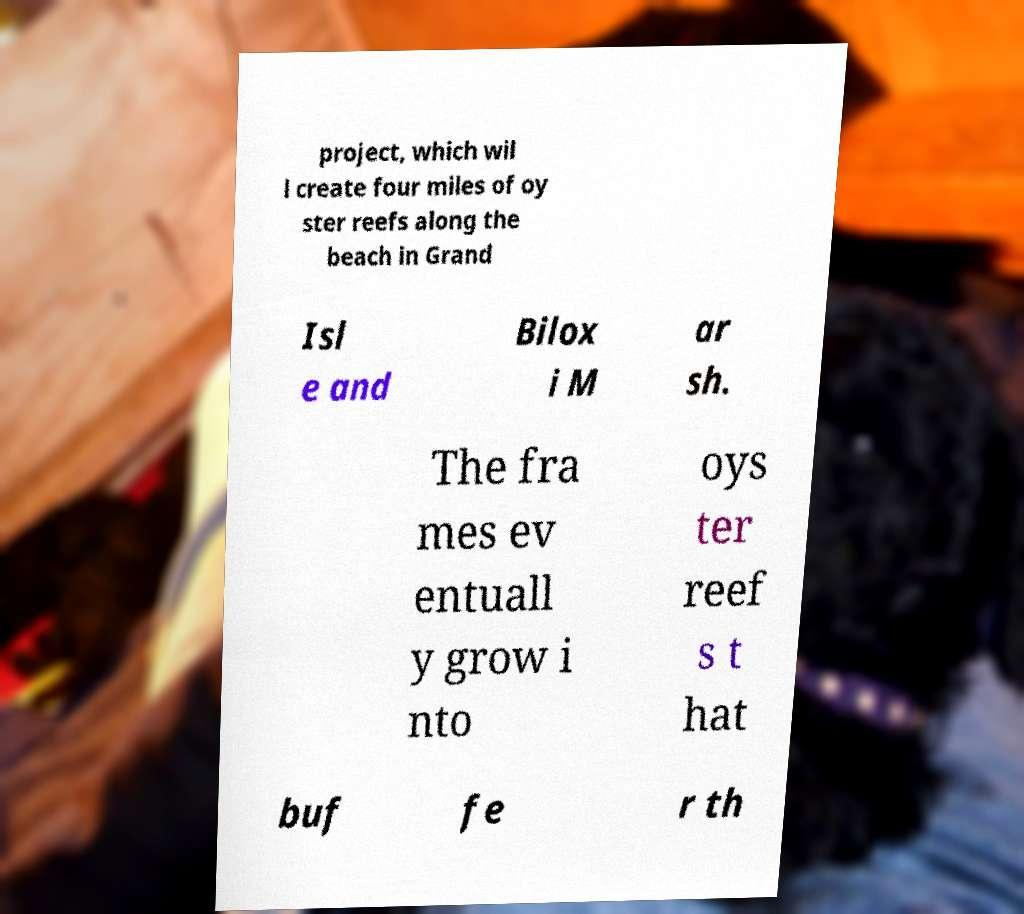I need the written content from this picture converted into text. Can you do that? project, which wil l create four miles of oy ster reefs along the beach in Grand Isl e and Bilox i M ar sh. The fra mes ev entuall y grow i nto oys ter reef s t hat buf fe r th 